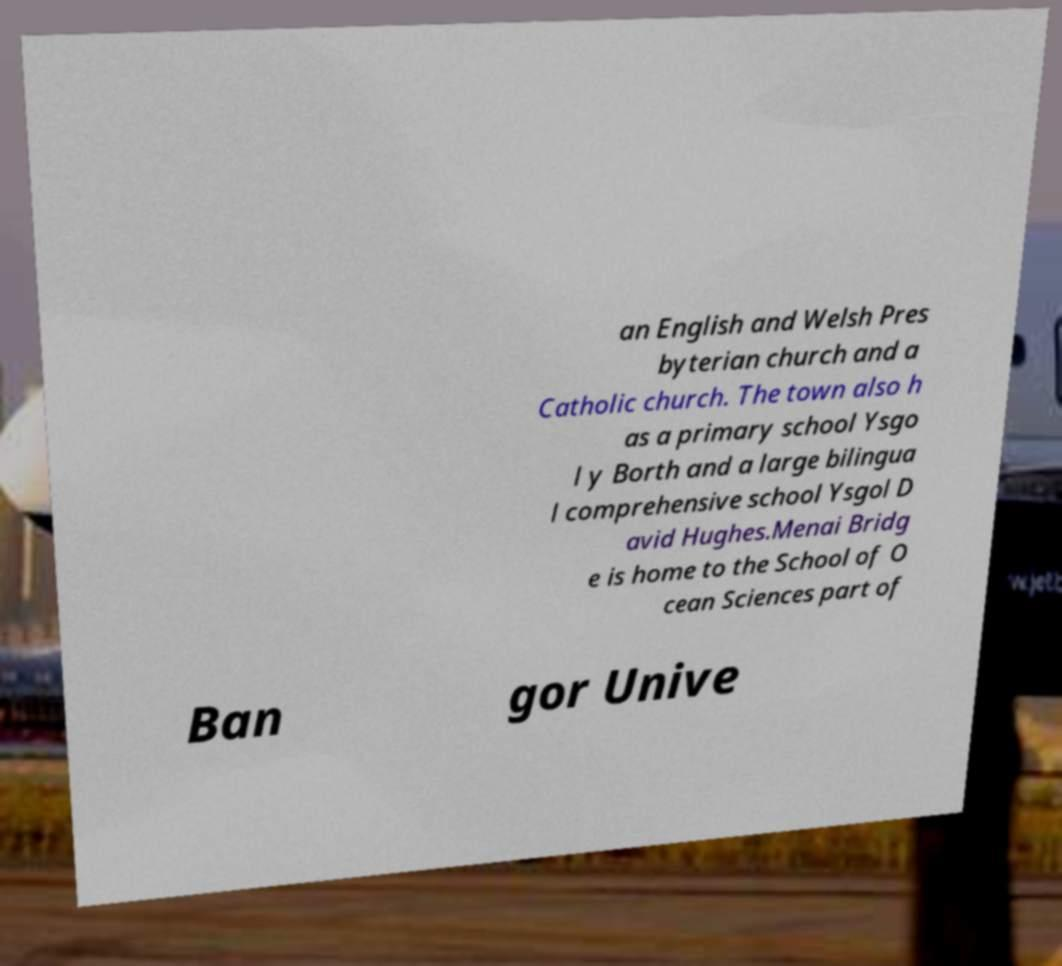For documentation purposes, I need the text within this image transcribed. Could you provide that? an English and Welsh Pres byterian church and a Catholic church. The town also h as a primary school Ysgo l y Borth and a large bilingua l comprehensive school Ysgol D avid Hughes.Menai Bridg e is home to the School of O cean Sciences part of Ban gor Unive 